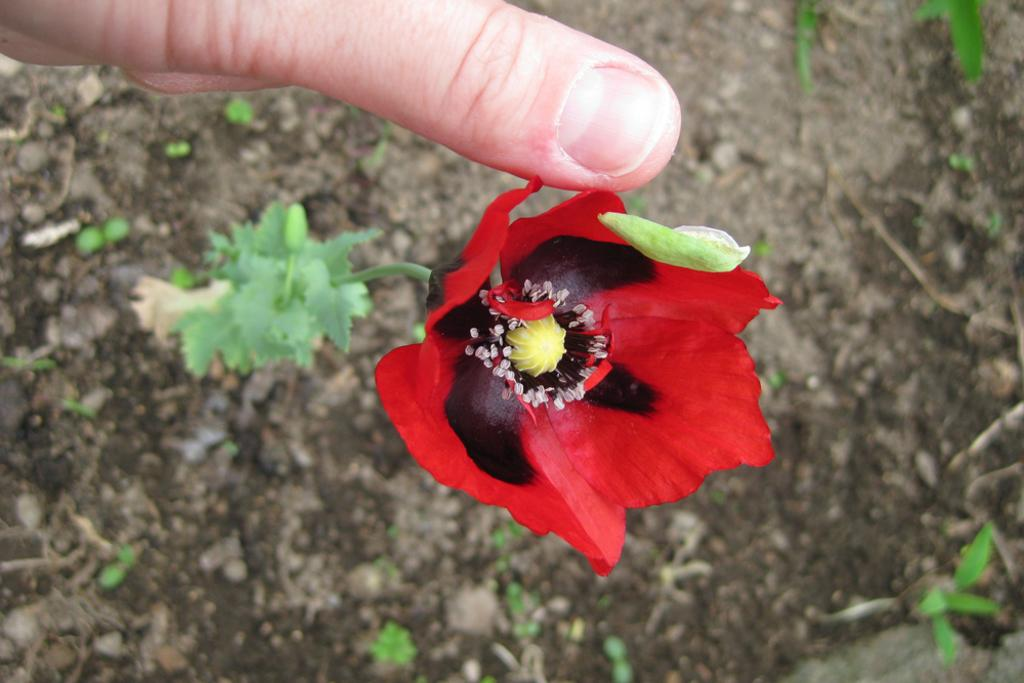What type of flower is in the image? There is a red flower in the image. What is the flower attached to? The flower is part of a plant. What is the person in the image doing with the flower? A person is touching the flower with their thumb finger. What can be seen around the plant in the image? There is a lot of soil around the plant. What time is the person starting to cook in the image? There is no indication of cooking or time in the image; it features a person touching a red flower on a plant surrounded by soil. 